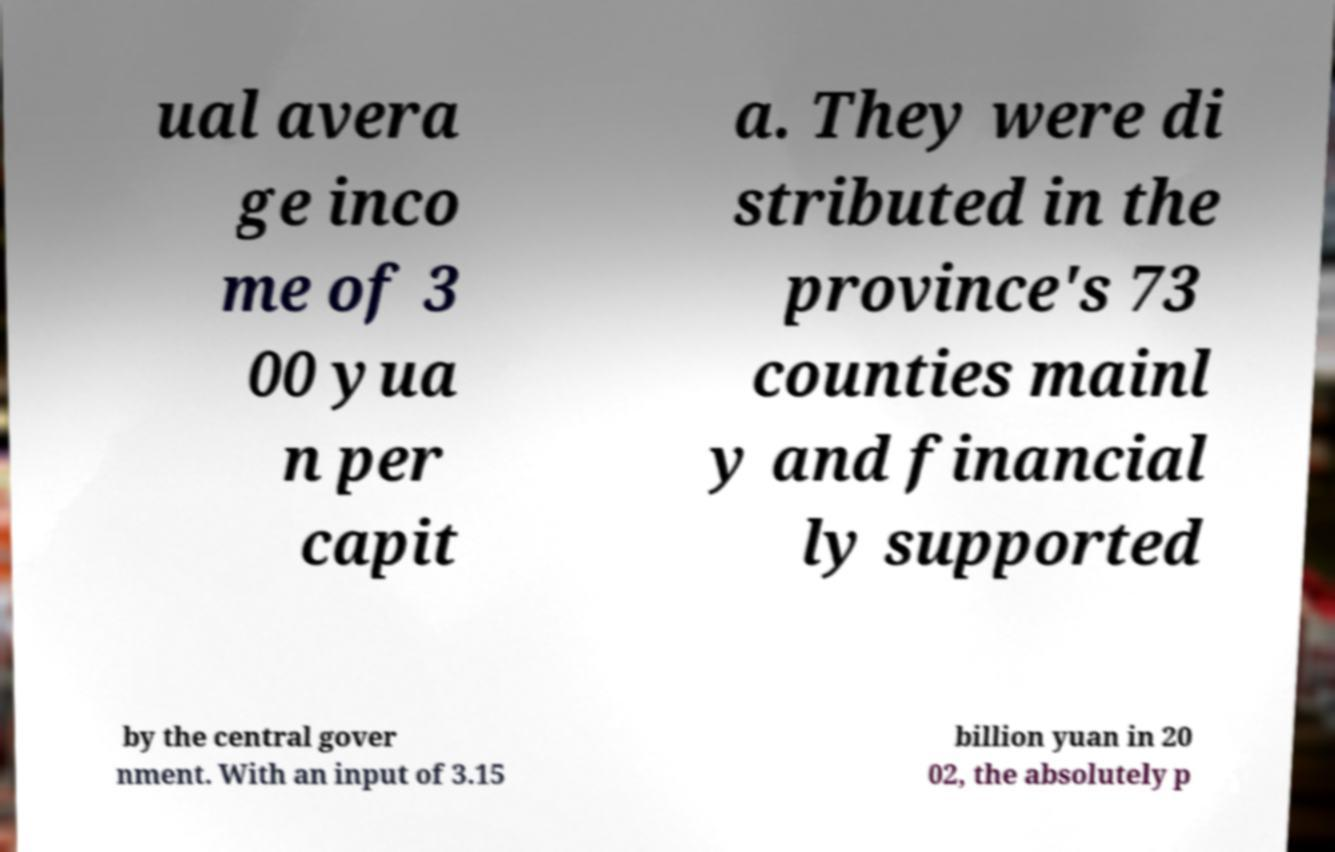Can you read and provide the text displayed in the image?This photo seems to have some interesting text. Can you extract and type it out for me? ual avera ge inco me of 3 00 yua n per capit a. They were di stributed in the province's 73 counties mainl y and financial ly supported by the central gover nment. With an input of 3.15 billion yuan in 20 02, the absolutely p 